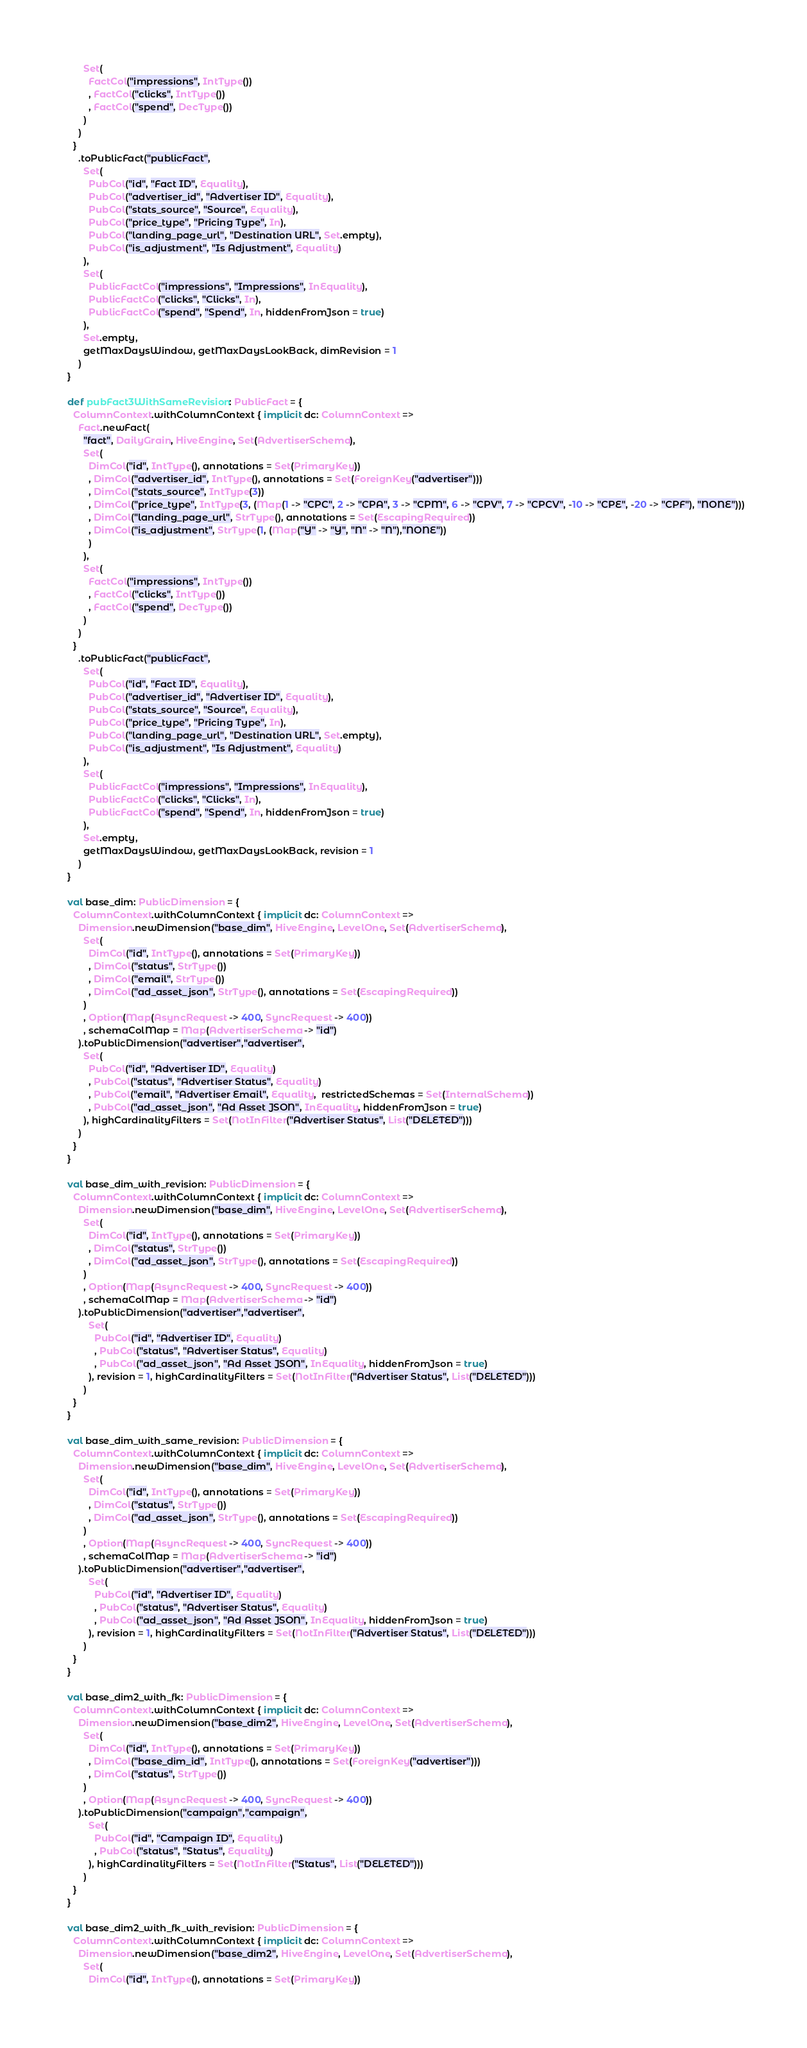Convert code to text. <code><loc_0><loc_0><loc_500><loc_500><_Scala_>        Set(
          FactCol("impressions", IntType())
          , FactCol("clicks", IntType())
          , FactCol("spend", DecType())
        )
      )
    }
      .toPublicFact("publicFact",
        Set(
          PubCol("id", "Fact ID", Equality),
          PubCol("advertiser_id", "Advertiser ID", Equality),
          PubCol("stats_source", "Source", Equality),
          PubCol("price_type", "Pricing Type", In),
          PubCol("landing_page_url", "Destination URL", Set.empty),
          PubCol("is_adjustment", "Is Adjustment", Equality)
        ),
        Set(
          PublicFactCol("impressions", "Impressions", InEquality),
          PublicFactCol("clicks", "Clicks", In),
          PublicFactCol("spend", "Spend", In, hiddenFromJson = true)
        ),
        Set.empty,
        getMaxDaysWindow, getMaxDaysLookBack, dimRevision = 1
      )
  }

  def pubFact3WithSameRevision: PublicFact = {
    ColumnContext.withColumnContext { implicit dc: ColumnContext =>
      Fact.newFact(
        "fact", DailyGrain, HiveEngine, Set(AdvertiserSchema),
        Set(
          DimCol("id", IntType(), annotations = Set(PrimaryKey))
          , DimCol("advertiser_id", IntType(), annotations = Set(ForeignKey("advertiser")))
          , DimCol("stats_source", IntType(3))
          , DimCol("price_type", IntType(3, (Map(1 -> "CPC", 2 -> "CPA", 3 -> "CPM", 6 -> "CPV", 7 -> "CPCV", -10 -> "CPE", -20 -> "CPF"), "NONE")))
          , DimCol("landing_page_url", StrType(), annotations = Set(EscapingRequired))
          , DimCol("is_adjustment", StrType(1, (Map("Y" -> "Y", "N" -> "N"),"NONE"))
          )
        ),
        Set(
          FactCol("impressions", IntType())
          , FactCol("clicks", IntType())
          , FactCol("spend", DecType())
        )
      )
    }
      .toPublicFact("publicFact",
        Set(
          PubCol("id", "Fact ID", Equality),
          PubCol("advertiser_id", "Advertiser ID", Equality),
          PubCol("stats_source", "Source", Equality),
          PubCol("price_type", "Pricing Type", In),
          PubCol("landing_page_url", "Destination URL", Set.empty),
          PubCol("is_adjustment", "Is Adjustment", Equality)
        ),
        Set(
          PublicFactCol("impressions", "Impressions", InEquality),
          PublicFactCol("clicks", "Clicks", In),
          PublicFactCol("spend", "Spend", In, hiddenFromJson = true)
        ),
        Set.empty,
        getMaxDaysWindow, getMaxDaysLookBack, revision = 1
      )
  }

  val base_dim: PublicDimension = {
    ColumnContext.withColumnContext { implicit dc: ColumnContext =>
      Dimension.newDimension("base_dim", HiveEngine, LevelOne, Set(AdvertiserSchema),
        Set(
          DimCol("id", IntType(), annotations = Set(PrimaryKey))
          , DimCol("status", StrType())
          , DimCol("email", StrType())
          , DimCol("ad_asset_json", StrType(), annotations = Set(EscapingRequired))
        )
        , Option(Map(AsyncRequest -> 400, SyncRequest -> 400))
        , schemaColMap = Map(AdvertiserSchema -> "id")
      ).toPublicDimension("advertiser","advertiser",
        Set(
          PubCol("id", "Advertiser ID", Equality)
          , PubCol("status", "Advertiser Status", Equality)
          , PubCol("email", "Advertiser Email", Equality,  restrictedSchemas = Set(InternalSchema))
          , PubCol("ad_asset_json", "Ad Asset JSON", InEquality, hiddenFromJson = true)
        ), highCardinalityFilters = Set(NotInFilter("Advertiser Status", List("DELETED")))
      )
    }
  }

  val base_dim_with_revision: PublicDimension = {
    ColumnContext.withColumnContext { implicit dc: ColumnContext =>
      Dimension.newDimension("base_dim", HiveEngine, LevelOne, Set(AdvertiserSchema),
        Set(
          DimCol("id", IntType(), annotations = Set(PrimaryKey))
          , DimCol("status", StrType())
          , DimCol("ad_asset_json", StrType(), annotations = Set(EscapingRequired))
        )
        , Option(Map(AsyncRequest -> 400, SyncRequest -> 400))
        , schemaColMap = Map(AdvertiserSchema -> "id")
      ).toPublicDimension("advertiser","advertiser",
          Set(
            PubCol("id", "Advertiser ID", Equality)
            , PubCol("status", "Advertiser Status", Equality)
            , PubCol("ad_asset_json", "Ad Asset JSON", InEquality, hiddenFromJson = true)
          ), revision = 1, highCardinalityFilters = Set(NotInFilter("Advertiser Status", List("DELETED")))
        )
    }
  }

  val base_dim_with_same_revision: PublicDimension = {
    ColumnContext.withColumnContext { implicit dc: ColumnContext =>
      Dimension.newDimension("base_dim", HiveEngine, LevelOne, Set(AdvertiserSchema),
        Set(
          DimCol("id", IntType(), annotations = Set(PrimaryKey))
          , DimCol("status", StrType())
          , DimCol("ad_asset_json", StrType(), annotations = Set(EscapingRequired))
        )
        , Option(Map(AsyncRequest -> 400, SyncRequest -> 400))
        , schemaColMap = Map(AdvertiserSchema -> "id")
      ).toPublicDimension("advertiser","advertiser",
          Set(
            PubCol("id", "Advertiser ID", Equality)
            , PubCol("status", "Advertiser Status", Equality)
            , PubCol("ad_asset_json", "Ad Asset JSON", InEquality, hiddenFromJson = true)
          ), revision = 1, highCardinalityFilters = Set(NotInFilter("Advertiser Status", List("DELETED")))
        )
    }
  }

  val base_dim2_with_fk: PublicDimension = {
    ColumnContext.withColumnContext { implicit dc: ColumnContext =>
      Dimension.newDimension("base_dim2", HiveEngine, LevelOne, Set(AdvertiserSchema),
        Set(
          DimCol("id", IntType(), annotations = Set(PrimaryKey))
          , DimCol("base_dim_id", IntType(), annotations = Set(ForeignKey("advertiser")))
          , DimCol("status", StrType())
        )
        , Option(Map(AsyncRequest -> 400, SyncRequest -> 400))
      ).toPublicDimension("campaign","campaign",
          Set(
            PubCol("id", "Campaign ID", Equality)
            , PubCol("status", "Status", Equality)
          ), highCardinalityFilters = Set(NotInFilter("Status", List("DELETED")))
        )
    }
  }

  val base_dim2_with_fk_with_revision: PublicDimension = {
    ColumnContext.withColumnContext { implicit dc: ColumnContext =>
      Dimension.newDimension("base_dim2", HiveEngine, LevelOne, Set(AdvertiserSchema),
        Set(
          DimCol("id", IntType(), annotations = Set(PrimaryKey))</code> 